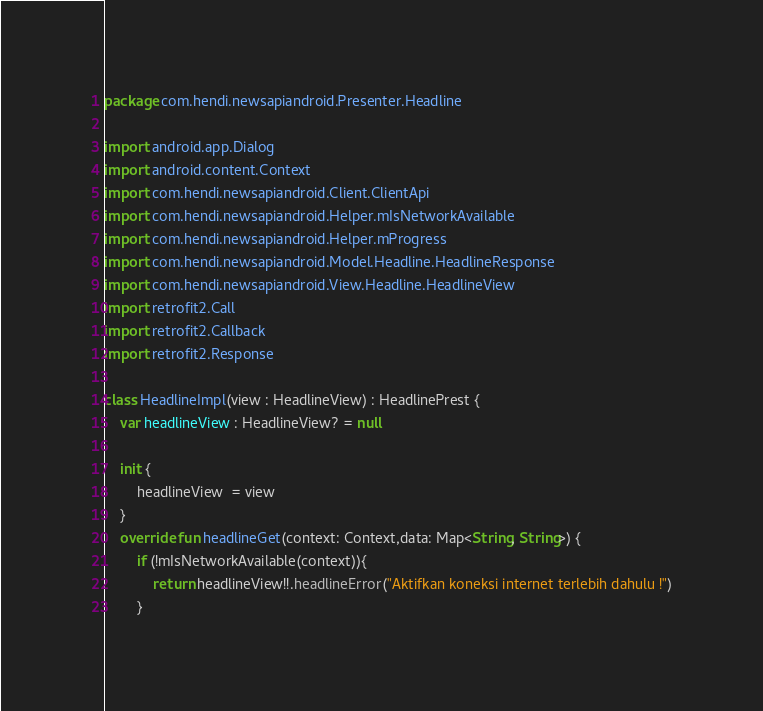Convert code to text. <code><loc_0><loc_0><loc_500><loc_500><_Kotlin_>package com.hendi.newsapiandroid.Presenter.Headline

import android.app.Dialog
import android.content.Context
import com.hendi.newsapiandroid.Client.ClientApi
import com.hendi.newsapiandroid.Helper.mIsNetworkAvailable
import com.hendi.newsapiandroid.Helper.mProgress
import com.hendi.newsapiandroid.Model.Headline.HeadlineResponse
import com.hendi.newsapiandroid.View.Headline.HeadlineView
import retrofit2.Call
import retrofit2.Callback
import retrofit2.Response

class HeadlineImpl(view : HeadlineView) : HeadlinePrest {
    var headlineView : HeadlineView? = null

    init {
        headlineView  = view
    }
    override fun headlineGet(context: Context,data: Map<String, String>) {
        if (!mIsNetworkAvailable(context)){
            return headlineView!!.headlineError("Aktifkan koneksi internet terlebih dahulu !")
        }</code> 